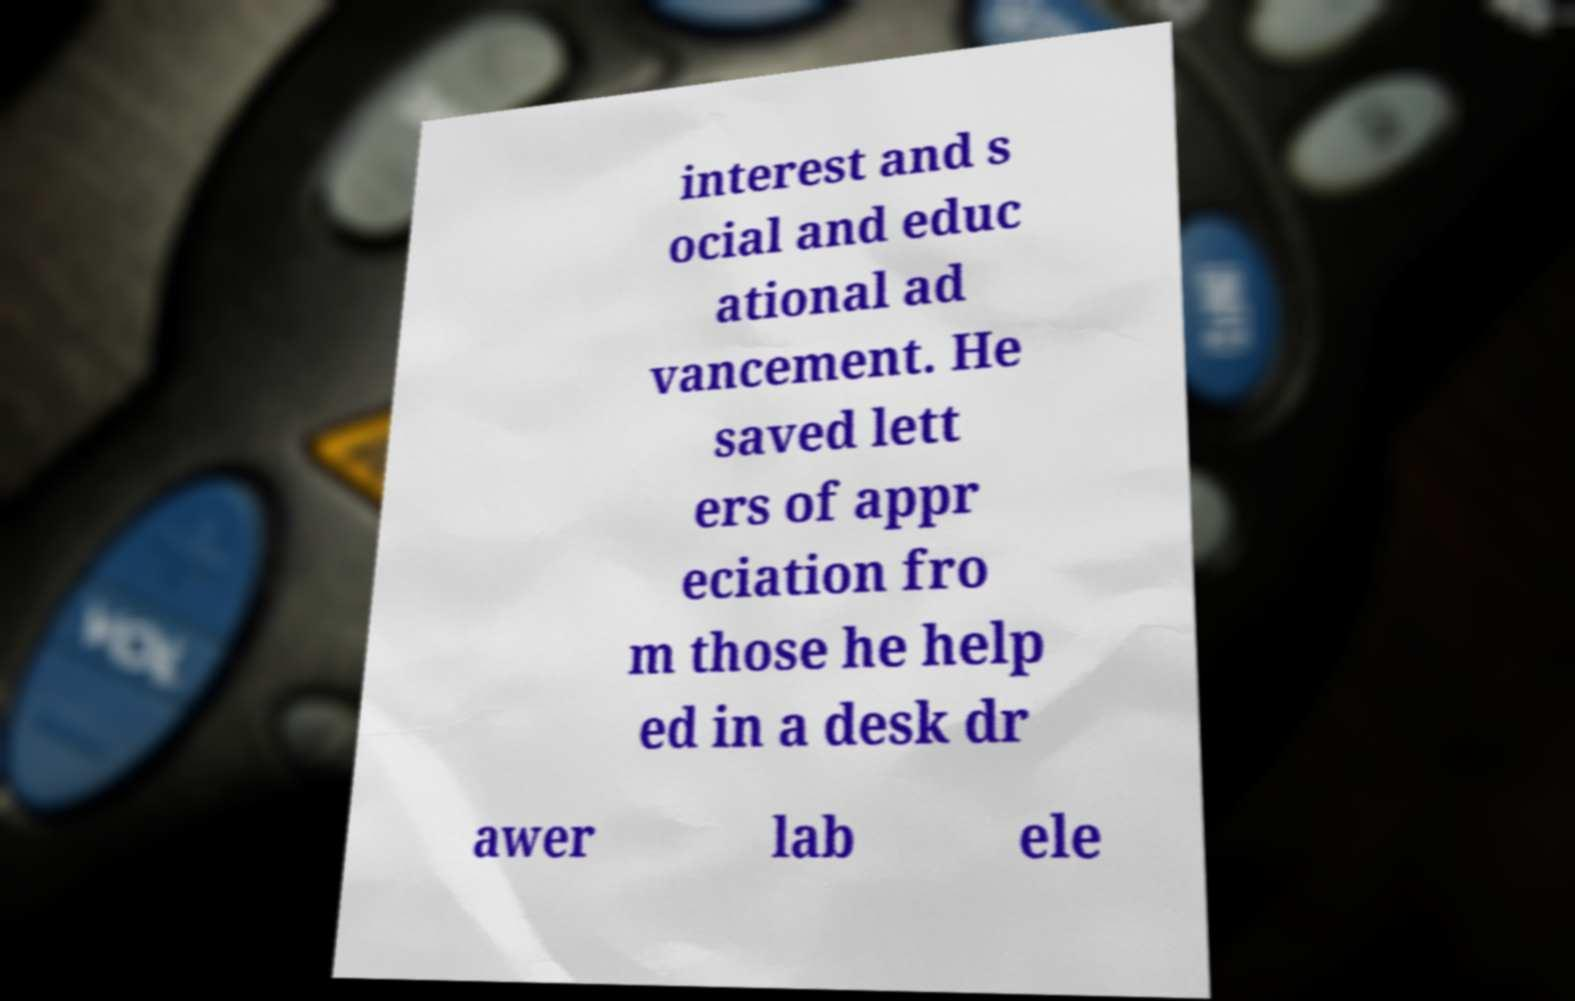Can you read and provide the text displayed in the image?This photo seems to have some interesting text. Can you extract and type it out for me? interest and s ocial and educ ational ad vancement. He saved lett ers of appr eciation fro m those he help ed in a desk dr awer lab ele 